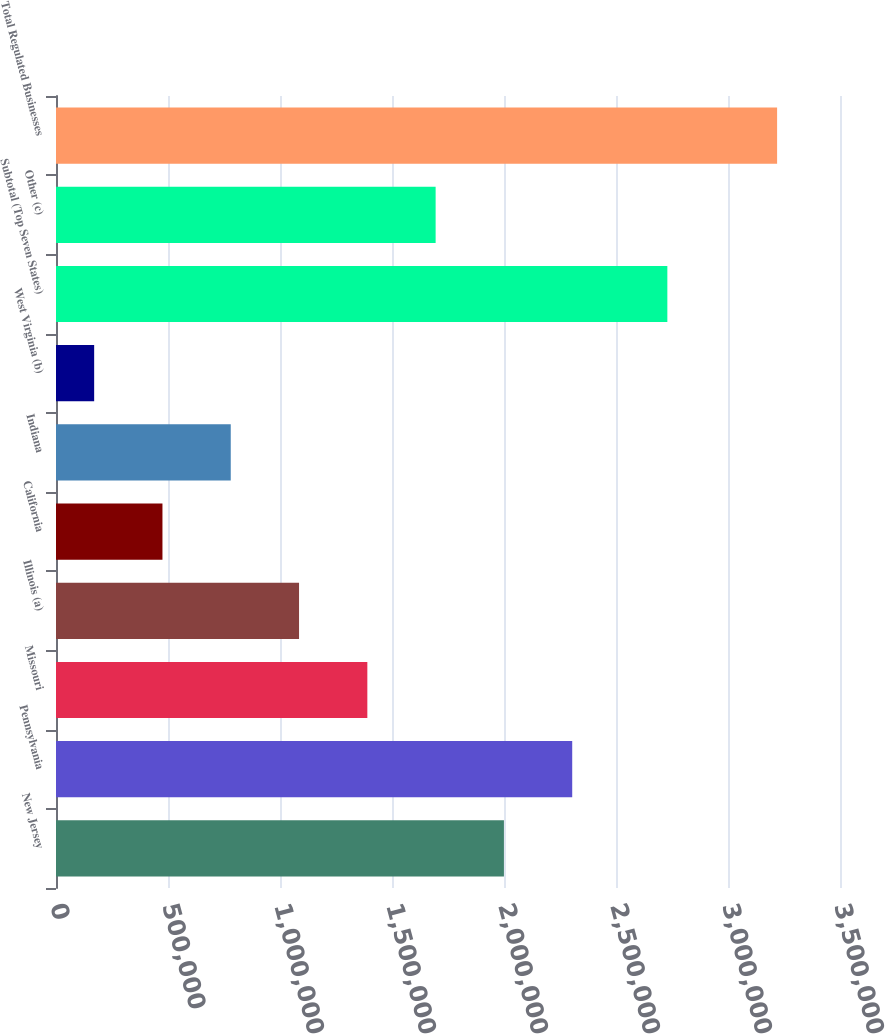<chart> <loc_0><loc_0><loc_500><loc_500><bar_chart><fcel>New Jersey<fcel>Pennsylvania<fcel>Missouri<fcel>Illinois (a)<fcel>California<fcel>Indiana<fcel>West Virginia (b)<fcel>Subtotal (Top Seven States)<fcel>Other (c)<fcel>Total Regulated Businesses<nl><fcel>1.99966e+06<fcel>2.30455e+06<fcel>1.3899e+06<fcel>1.08502e+06<fcel>475253<fcel>780135<fcel>170371<fcel>2.72923e+06<fcel>1.69478e+06<fcel>3.21919e+06<nl></chart> 